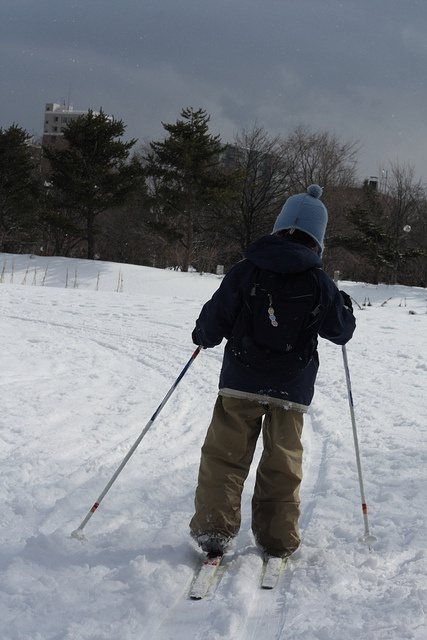Describe the objects in this image and their specific colors. I can see people in gray and black tones, backpack in gray, black, and blue tones, and skis in gray, darkgray, and black tones in this image. 